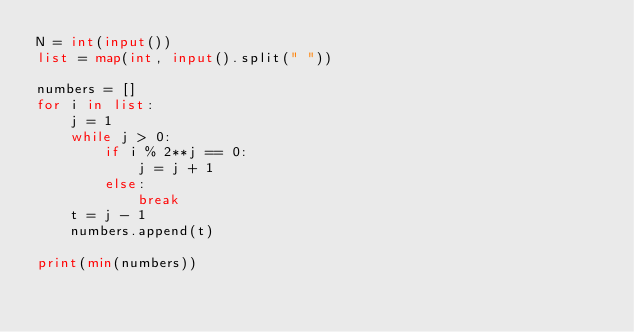<code> <loc_0><loc_0><loc_500><loc_500><_Python_>N = int(input())
list = map(int, input().split(" "))

numbers = []
for i in list:
    j = 1
    while j > 0:
        if i % 2**j == 0:
            j = j + 1
        else:
            break
    t = j - 1
    numbers.append(t)
    
print(min(numbers))</code> 